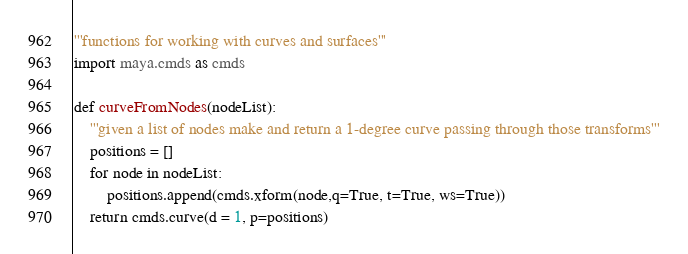<code> <loc_0><loc_0><loc_500><loc_500><_Python_>'''functions for working with curves and surfaces'''
import maya.cmds as cmds

def curveFromNodes(nodeList):
    '''given a list of nodes make and return a 1-degree curve passing through those transforms'''
    positions = []
    for node in nodeList:
        positions.append(cmds.xform(node,q=True, t=True, ws=True))
    return cmds.curve(d = 1, p=positions)</code> 